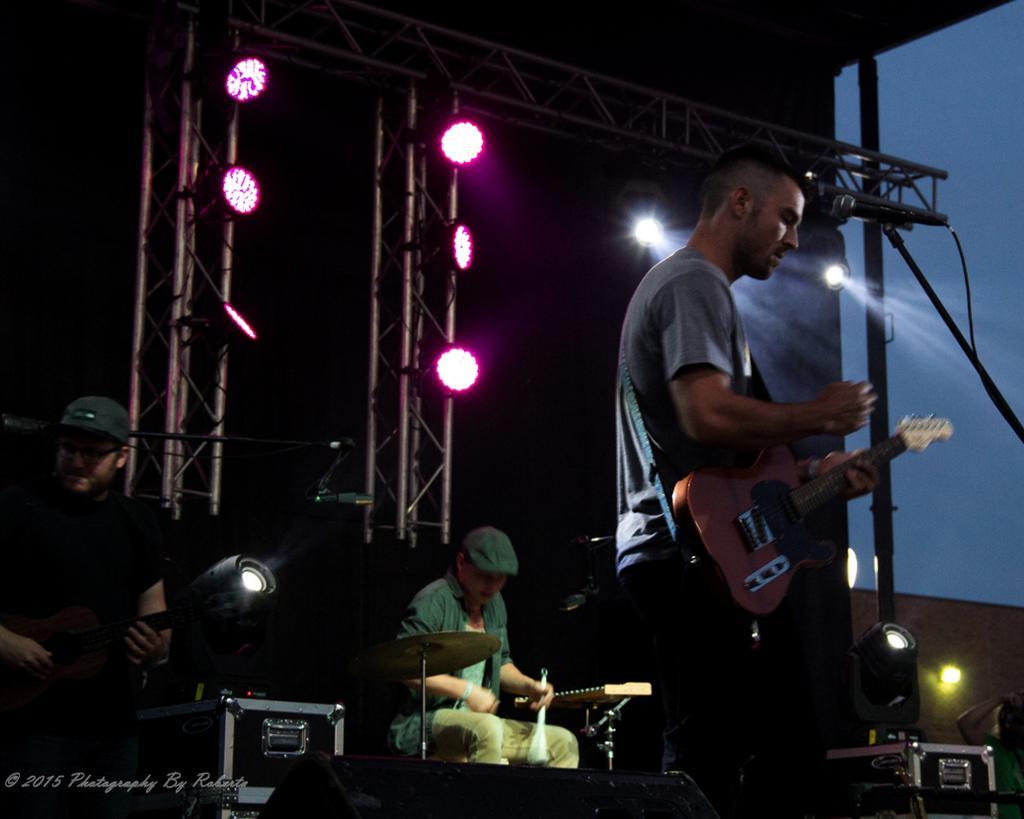In one or two sentences, can you explain what this image depicts? In this picture we can see three men on stage playing musical instruments such as guitar, drums and here person singing on mic and in background we can see pillar with lights. 